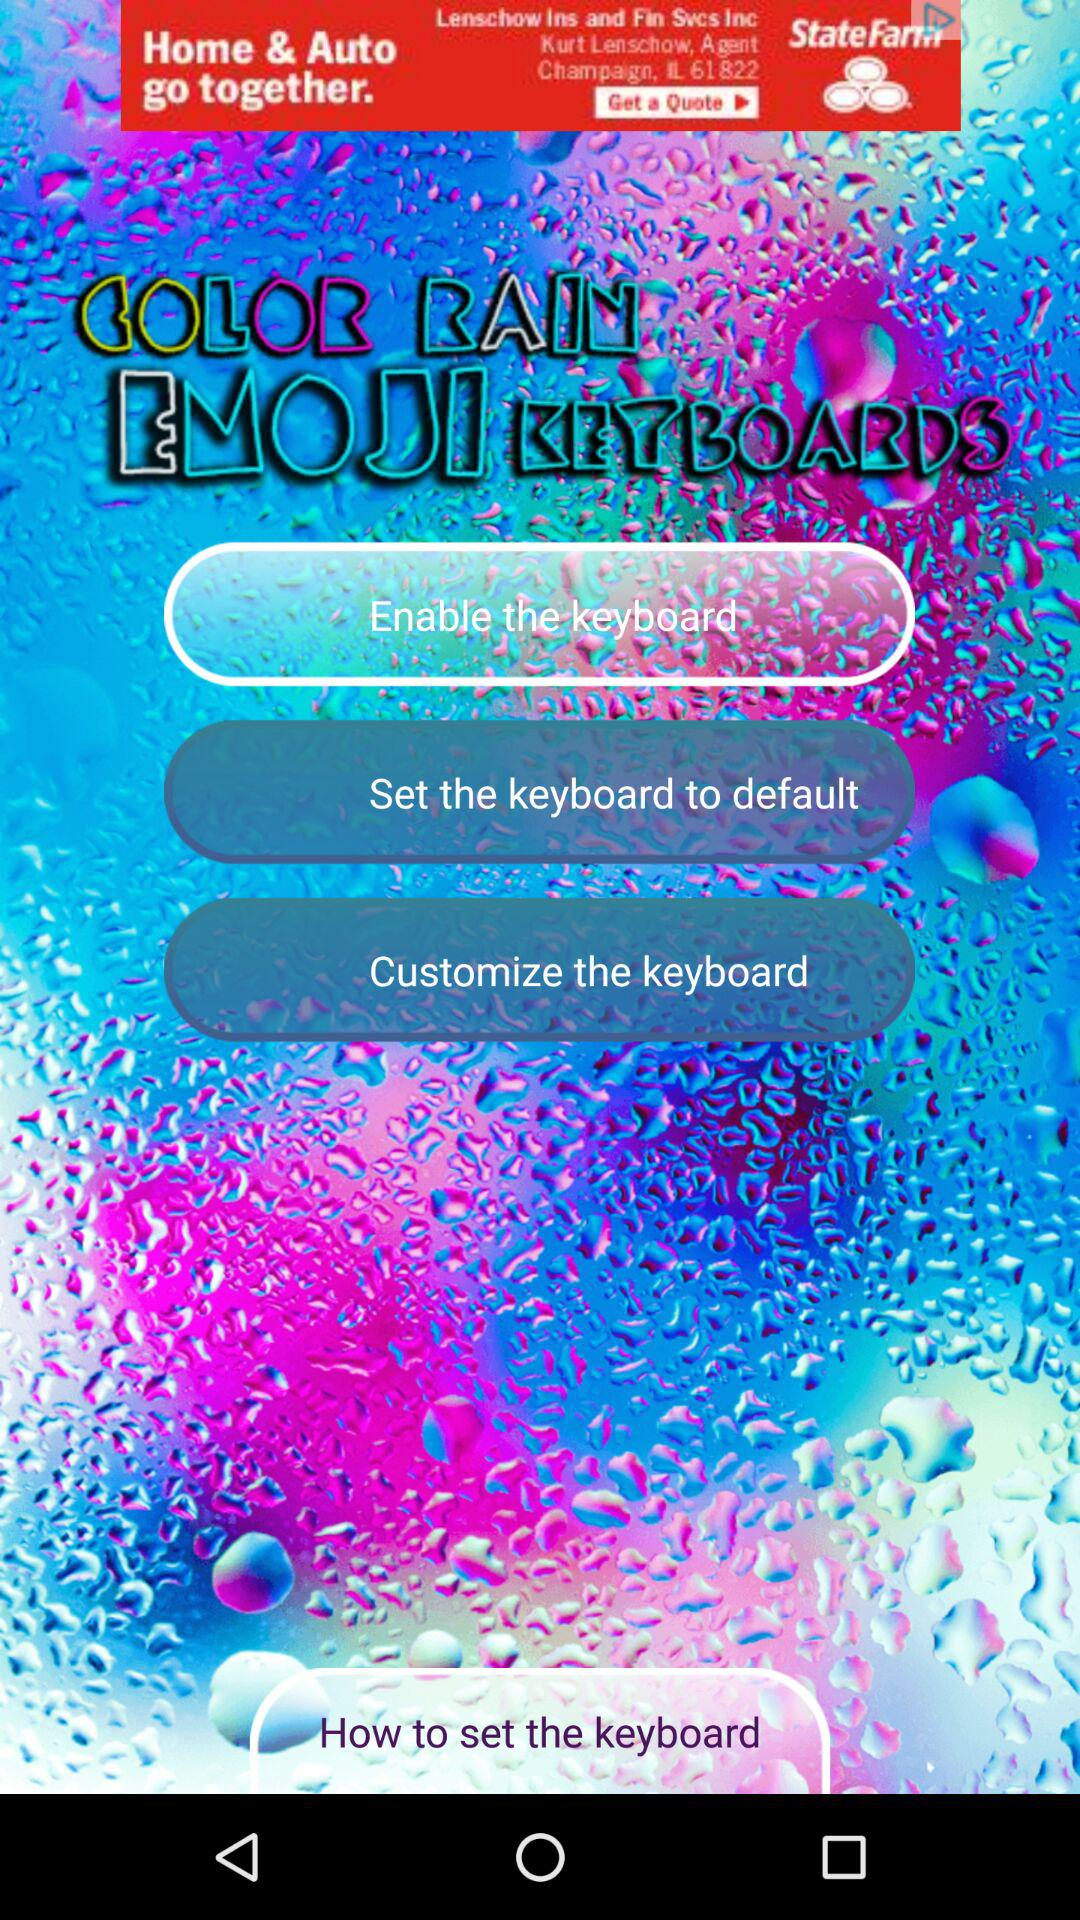What is the name of the application? The name of the application is "COLOR RAIN EMOJI KEYBOARDS". 